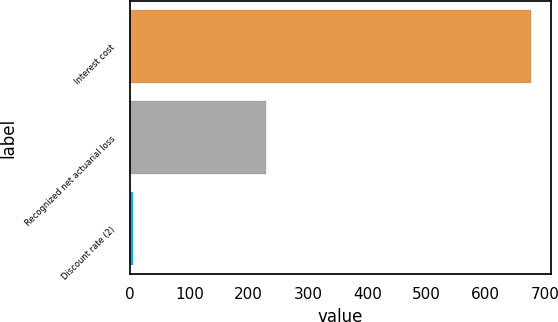Convert chart. <chart><loc_0><loc_0><loc_500><loc_500><bar_chart><fcel>Interest cost<fcel>Recognized net actuarial loss<fcel>Discount rate (2)<nl><fcel>676<fcel>229<fcel>5.5<nl></chart> 